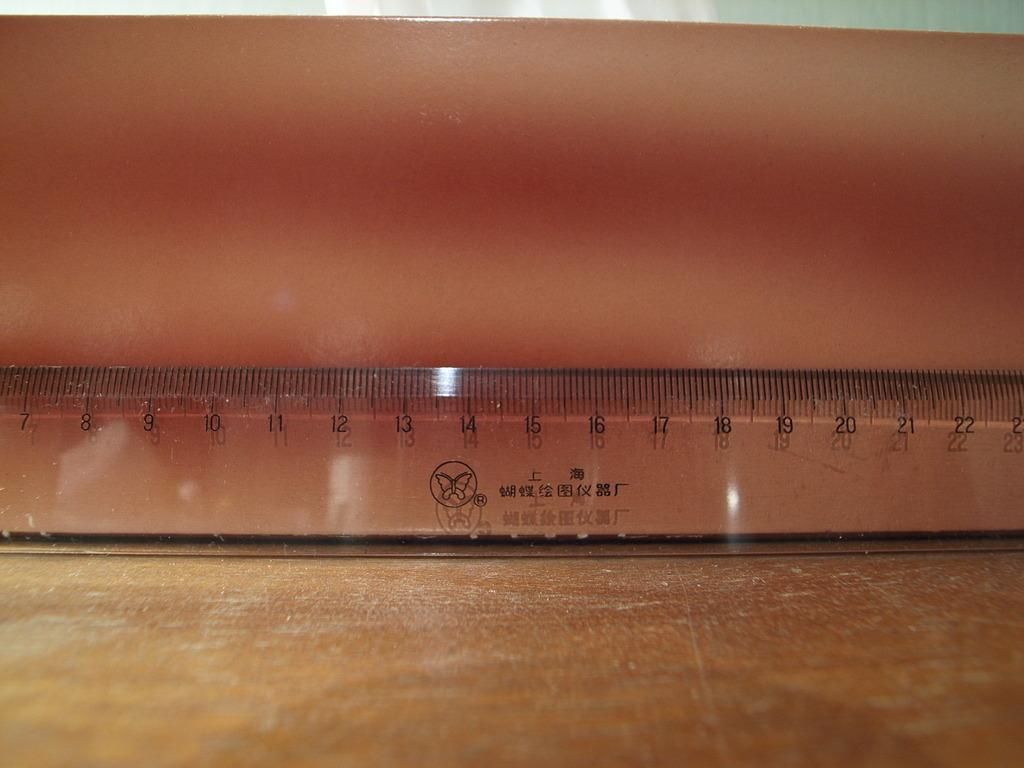<image>
Create a compact narrative representing the image presented. A see through Chinese ruler with centimeter marks between 7 and 22 are displayed. 